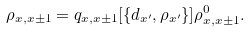<formula> <loc_0><loc_0><loc_500><loc_500>\rho _ { x , x \pm 1 } = q _ { x , x \pm 1 } [ \{ d _ { x ^ { \prime } } , \rho _ { x ^ { \prime } } \} ] \rho _ { x , x \pm 1 } ^ { 0 } .</formula> 